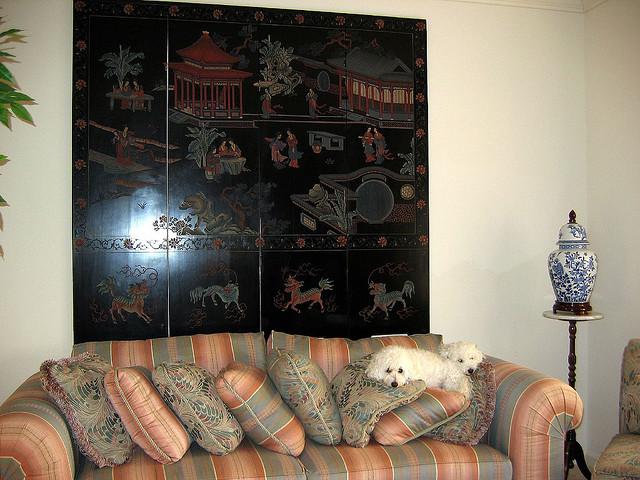Is that piece of artwork oriental?
Concise answer only. Yes. Do the dogs look comfortable?
Quick response, please. Yes. How many dogs are on the couch?
Write a very short answer. 2. 